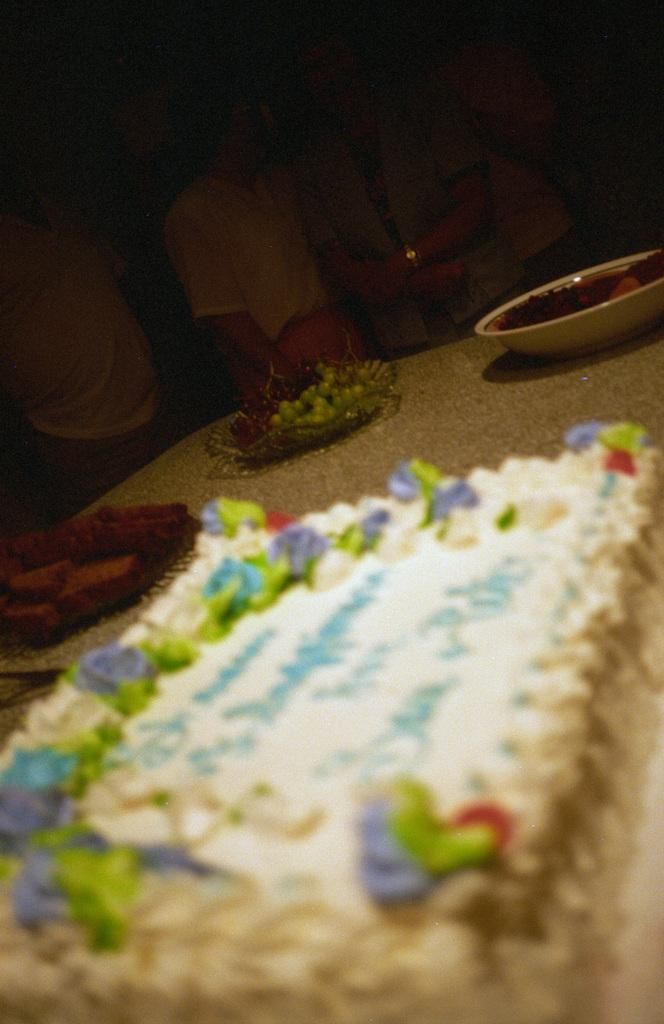What is the main food item featured in the image? There is a cake in the image. What other food items can be seen in the image? There are food items in a bowl in the image. Can you describe the setting or context of the image? There are people in the background of the image. What type of scent can be detected coming from the crayon in the image? There is no crayon present in the image, so it is not possible to determine any scent. 